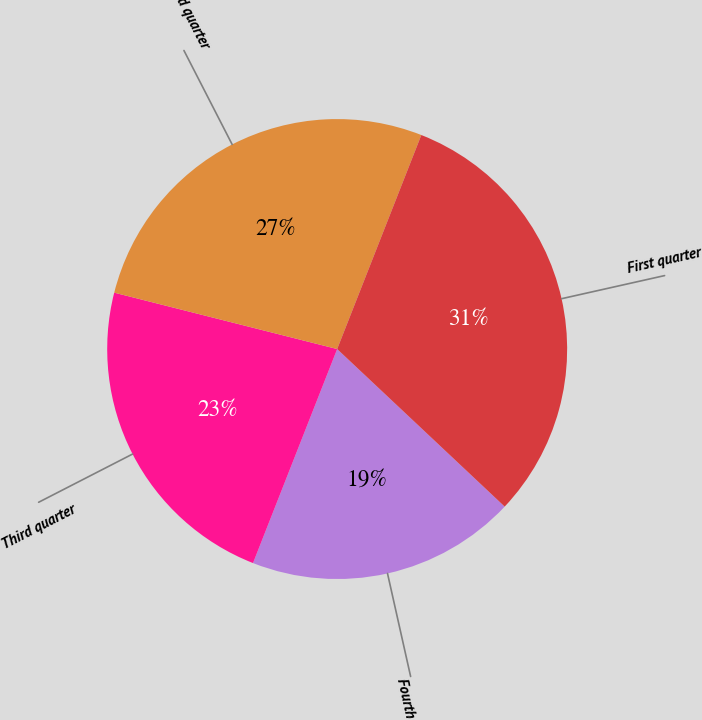<chart> <loc_0><loc_0><loc_500><loc_500><pie_chart><fcel>Fourth quarter<fcel>Third quarter<fcel>Second quarter<fcel>First quarter<nl><fcel>18.95%<fcel>22.98%<fcel>27.02%<fcel>31.05%<nl></chart> 